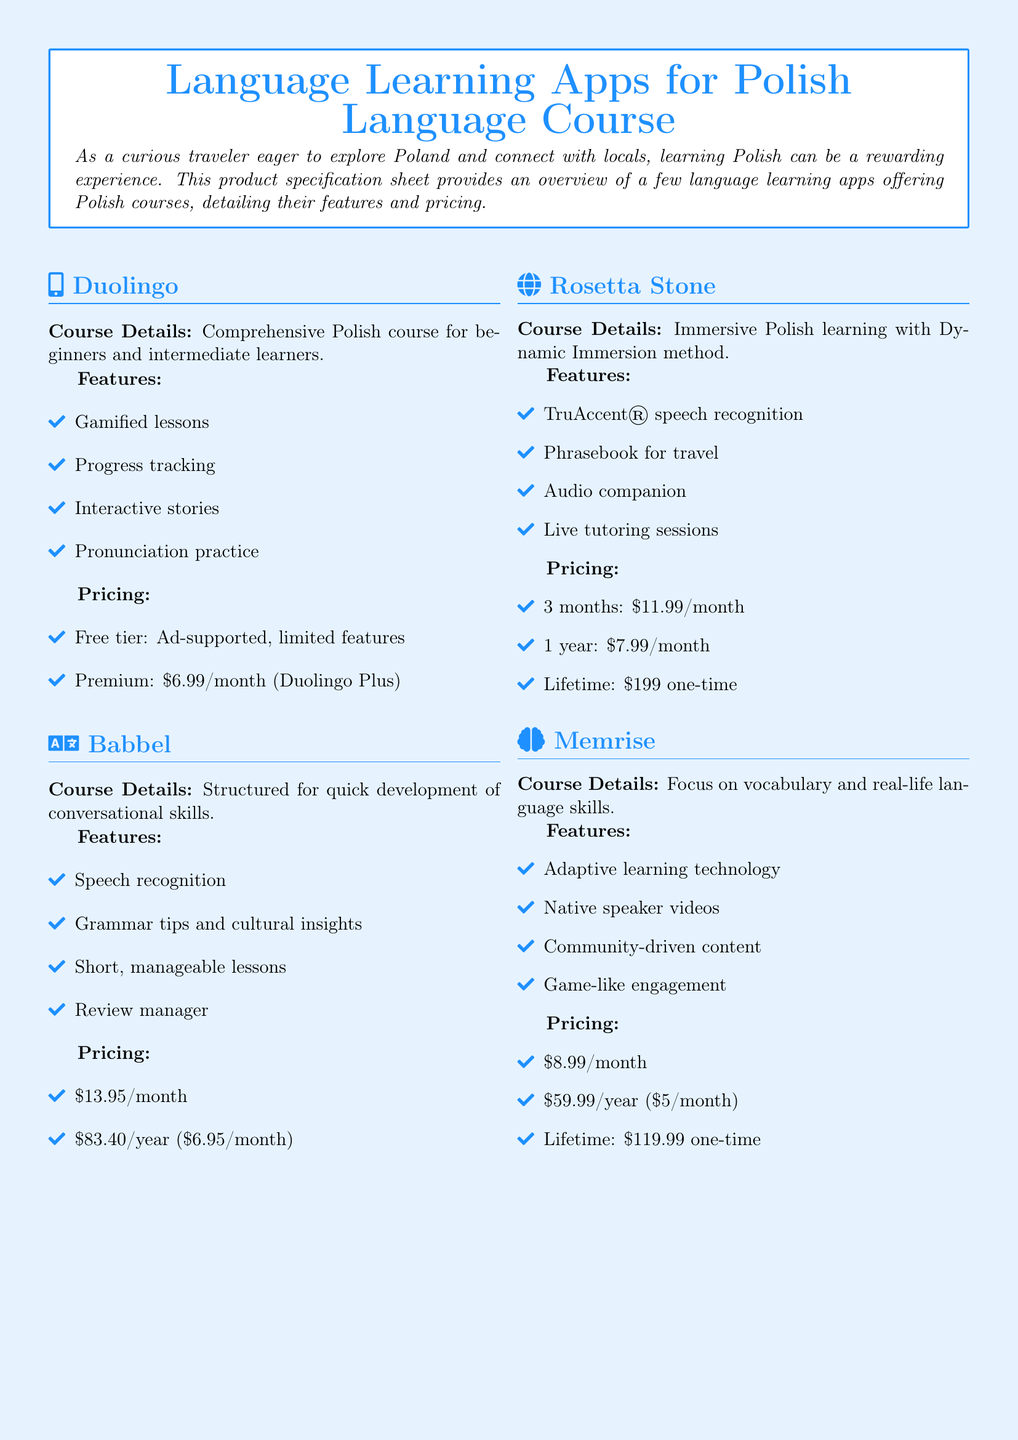What is the price of Duolingo Premium? Duolingo Premium is priced at $6.99 per month.
Answer: $6.99/month What feature does Babbel provide related to pronunciation? Babbel includes a speech recognition feature to assist with pronunciation.
Answer: Speech recognition How long is the pricing plan for Rosetta Stone's lifetime option? The lifetime option for Rosetta Stone is a one-time payment for unrestricted access.
Answer: One-time What is Memrise's annual subscription cost? Memrise offers an annual subscription for $59.99 which breaks down to $5/month.
Answer: $59.99/year Which app focuses on vocabulary and real-life language skills? Memrise is specifically focused on vocabulary and practical language application.
Answer: Memrise What method does Rosetta Stone use for its Polish learning course? Rosetta Stone employs the Dynamic Immersion method for its Polish course.
Answer: Dynamic Immersion How often are the lessons in Babbel designed to be? Babbel's lessons are structured to be short and manageable.
Answer: Short What additional resource does Rosetta Stone provide for travelers? Rosetta Stone includes a phrasebook specifically for travel assistance.
Answer: Phrasebook What is the primary target audience for Duolingo’s Polish course? Duolingo's Polish course is comprehensive for beginners and intermediate learners.
Answer: Beginners and intermediate learners 